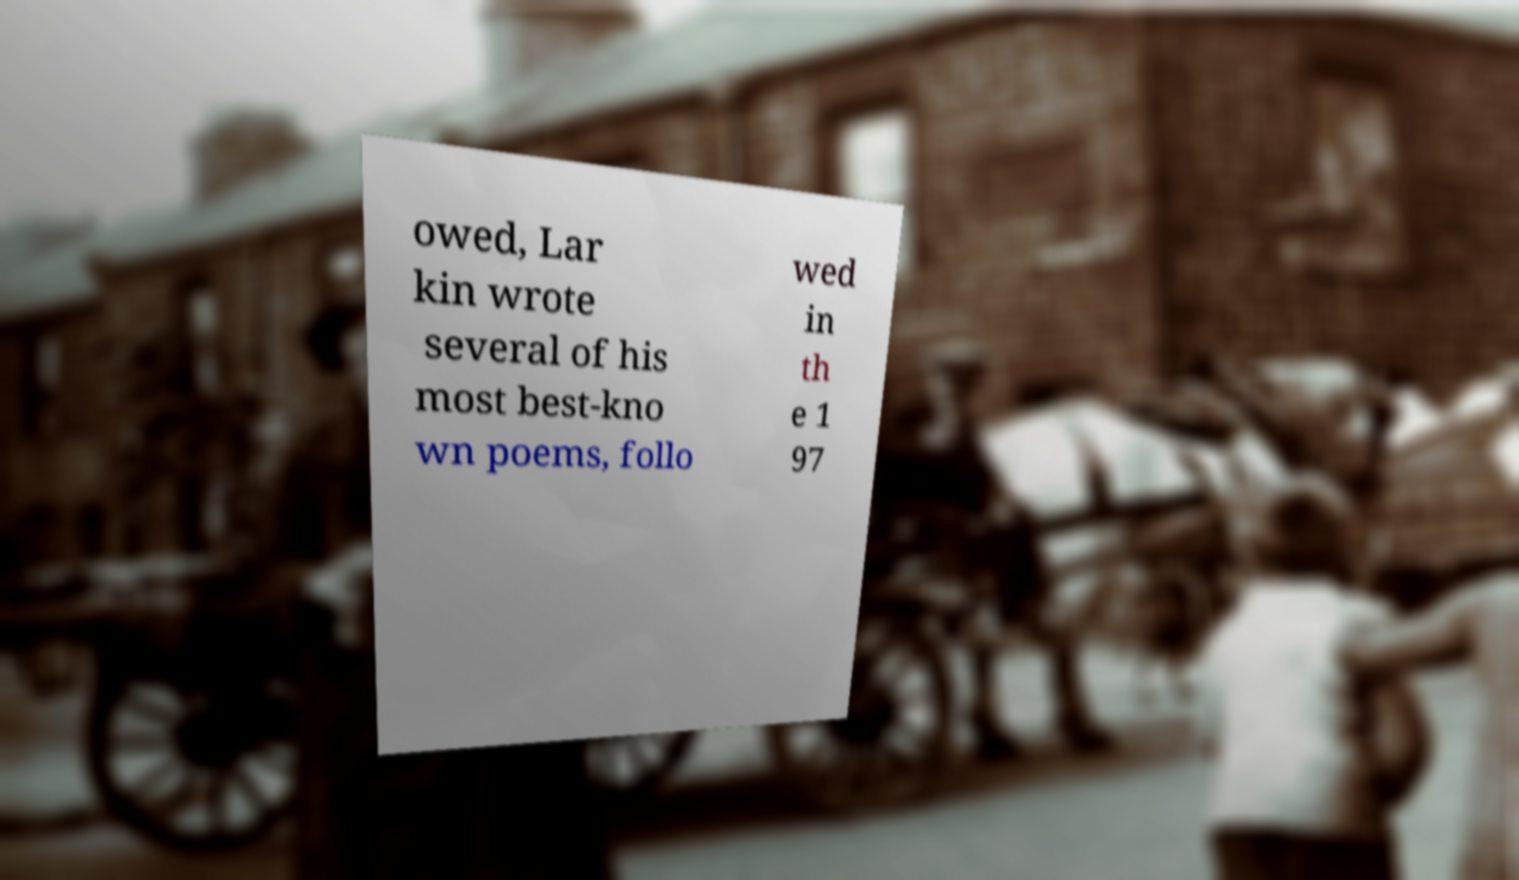Can you read and provide the text displayed in the image?This photo seems to have some interesting text. Can you extract and type it out for me? owed, Lar kin wrote several of his most best-kno wn poems, follo wed in th e 1 97 